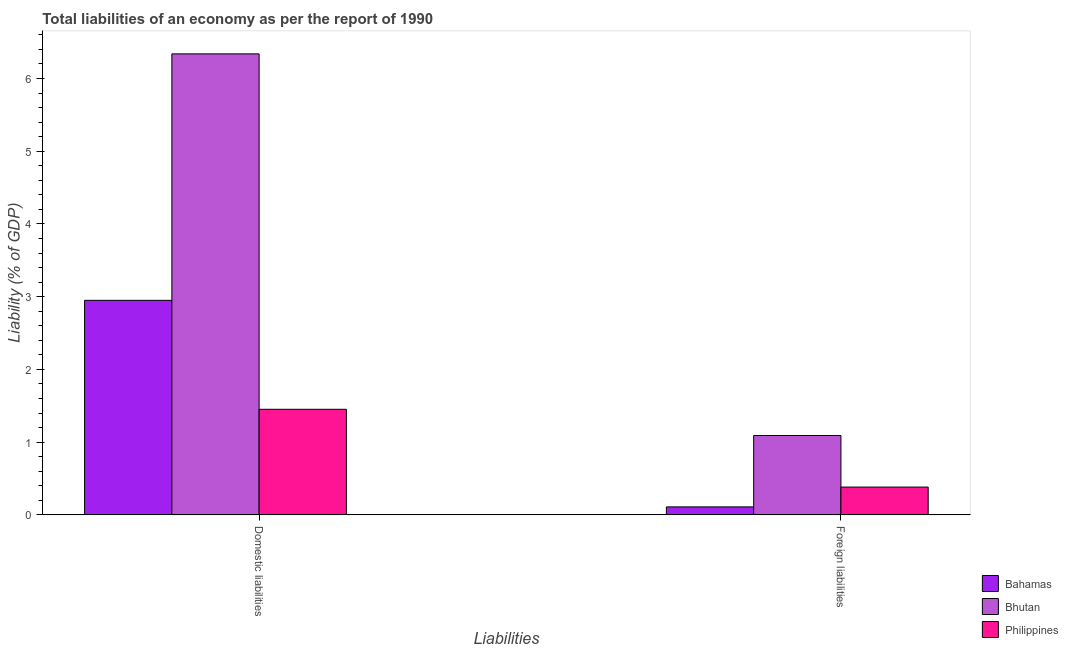How many groups of bars are there?
Your response must be concise. 2. Are the number of bars per tick equal to the number of legend labels?
Keep it short and to the point. Yes. Are the number of bars on each tick of the X-axis equal?
Your answer should be compact. Yes. How many bars are there on the 2nd tick from the left?
Ensure brevity in your answer.  3. How many bars are there on the 1st tick from the right?
Ensure brevity in your answer.  3. What is the label of the 2nd group of bars from the left?
Your answer should be very brief. Foreign liabilities. What is the incurrence of foreign liabilities in Bhutan?
Provide a short and direct response. 1.09. Across all countries, what is the maximum incurrence of domestic liabilities?
Offer a very short reply. 6.34. Across all countries, what is the minimum incurrence of foreign liabilities?
Offer a terse response. 0.11. In which country was the incurrence of foreign liabilities maximum?
Keep it short and to the point. Bhutan. In which country was the incurrence of foreign liabilities minimum?
Provide a succinct answer. Bahamas. What is the total incurrence of foreign liabilities in the graph?
Your response must be concise. 1.59. What is the difference between the incurrence of domestic liabilities in Philippines and that in Bhutan?
Offer a very short reply. -4.89. What is the difference between the incurrence of domestic liabilities in Bhutan and the incurrence of foreign liabilities in Philippines?
Provide a short and direct response. 5.96. What is the average incurrence of foreign liabilities per country?
Offer a very short reply. 0.53. What is the difference between the incurrence of domestic liabilities and incurrence of foreign liabilities in Philippines?
Ensure brevity in your answer.  1.07. What is the ratio of the incurrence of foreign liabilities in Philippines to that in Bhutan?
Provide a succinct answer. 0.35. Is the incurrence of foreign liabilities in Philippines less than that in Bahamas?
Your response must be concise. No. In how many countries, is the incurrence of domestic liabilities greater than the average incurrence of domestic liabilities taken over all countries?
Provide a short and direct response. 1. What does the 1st bar from the left in Foreign liabilities represents?
Ensure brevity in your answer.  Bahamas. What does the 3rd bar from the right in Foreign liabilities represents?
Keep it short and to the point. Bahamas. How many bars are there?
Keep it short and to the point. 6. Are all the bars in the graph horizontal?
Make the answer very short. No. How many countries are there in the graph?
Offer a terse response. 3. Are the values on the major ticks of Y-axis written in scientific E-notation?
Offer a terse response. No. Does the graph contain any zero values?
Keep it short and to the point. No. Does the graph contain grids?
Your answer should be compact. No. Where does the legend appear in the graph?
Your answer should be compact. Bottom right. How many legend labels are there?
Ensure brevity in your answer.  3. What is the title of the graph?
Ensure brevity in your answer.  Total liabilities of an economy as per the report of 1990. Does "Yemen, Rep." appear as one of the legend labels in the graph?
Make the answer very short. No. What is the label or title of the X-axis?
Offer a very short reply. Liabilities. What is the label or title of the Y-axis?
Make the answer very short. Liability (% of GDP). What is the Liability (% of GDP) in Bahamas in Domestic liabilities?
Provide a short and direct response. 2.95. What is the Liability (% of GDP) of Bhutan in Domestic liabilities?
Ensure brevity in your answer.  6.34. What is the Liability (% of GDP) of Philippines in Domestic liabilities?
Keep it short and to the point. 1.45. What is the Liability (% of GDP) of Bahamas in Foreign liabilities?
Keep it short and to the point. 0.11. What is the Liability (% of GDP) in Bhutan in Foreign liabilities?
Ensure brevity in your answer.  1.09. What is the Liability (% of GDP) in Philippines in Foreign liabilities?
Your answer should be very brief. 0.38. Across all Liabilities, what is the maximum Liability (% of GDP) in Bahamas?
Your answer should be very brief. 2.95. Across all Liabilities, what is the maximum Liability (% of GDP) of Bhutan?
Your answer should be very brief. 6.34. Across all Liabilities, what is the maximum Liability (% of GDP) in Philippines?
Offer a terse response. 1.45. Across all Liabilities, what is the minimum Liability (% of GDP) in Bahamas?
Ensure brevity in your answer.  0.11. Across all Liabilities, what is the minimum Liability (% of GDP) of Bhutan?
Your answer should be very brief. 1.09. Across all Liabilities, what is the minimum Liability (% of GDP) of Philippines?
Provide a succinct answer. 0.38. What is the total Liability (% of GDP) of Bahamas in the graph?
Give a very brief answer. 3.06. What is the total Liability (% of GDP) of Bhutan in the graph?
Your answer should be compact. 7.43. What is the total Liability (% of GDP) in Philippines in the graph?
Your response must be concise. 1.84. What is the difference between the Liability (% of GDP) in Bahamas in Domestic liabilities and that in Foreign liabilities?
Your response must be concise. 2.84. What is the difference between the Liability (% of GDP) in Bhutan in Domestic liabilities and that in Foreign liabilities?
Give a very brief answer. 5.25. What is the difference between the Liability (% of GDP) in Philippines in Domestic liabilities and that in Foreign liabilities?
Provide a short and direct response. 1.07. What is the difference between the Liability (% of GDP) of Bahamas in Domestic liabilities and the Liability (% of GDP) of Bhutan in Foreign liabilities?
Provide a short and direct response. 1.86. What is the difference between the Liability (% of GDP) of Bahamas in Domestic liabilities and the Liability (% of GDP) of Philippines in Foreign liabilities?
Provide a short and direct response. 2.57. What is the difference between the Liability (% of GDP) of Bhutan in Domestic liabilities and the Liability (% of GDP) of Philippines in Foreign liabilities?
Provide a succinct answer. 5.96. What is the average Liability (% of GDP) of Bahamas per Liabilities?
Give a very brief answer. 1.53. What is the average Liability (% of GDP) in Bhutan per Liabilities?
Make the answer very short. 3.71. What is the average Liability (% of GDP) of Philippines per Liabilities?
Your response must be concise. 0.92. What is the difference between the Liability (% of GDP) of Bahamas and Liability (% of GDP) of Bhutan in Domestic liabilities?
Ensure brevity in your answer.  -3.39. What is the difference between the Liability (% of GDP) of Bahamas and Liability (% of GDP) of Philippines in Domestic liabilities?
Give a very brief answer. 1.5. What is the difference between the Liability (% of GDP) of Bhutan and Liability (% of GDP) of Philippines in Domestic liabilities?
Provide a succinct answer. 4.89. What is the difference between the Liability (% of GDP) in Bahamas and Liability (% of GDP) in Bhutan in Foreign liabilities?
Your answer should be compact. -0.98. What is the difference between the Liability (% of GDP) in Bahamas and Liability (% of GDP) in Philippines in Foreign liabilities?
Your answer should be very brief. -0.27. What is the difference between the Liability (% of GDP) in Bhutan and Liability (% of GDP) in Philippines in Foreign liabilities?
Make the answer very short. 0.71. What is the ratio of the Liability (% of GDP) in Bahamas in Domestic liabilities to that in Foreign liabilities?
Provide a succinct answer. 26.69. What is the ratio of the Liability (% of GDP) of Bhutan in Domestic liabilities to that in Foreign liabilities?
Keep it short and to the point. 5.81. What is the ratio of the Liability (% of GDP) of Philippines in Domestic liabilities to that in Foreign liabilities?
Make the answer very short. 3.79. What is the difference between the highest and the second highest Liability (% of GDP) in Bahamas?
Provide a succinct answer. 2.84. What is the difference between the highest and the second highest Liability (% of GDP) of Bhutan?
Offer a very short reply. 5.25. What is the difference between the highest and the second highest Liability (% of GDP) in Philippines?
Provide a short and direct response. 1.07. What is the difference between the highest and the lowest Liability (% of GDP) of Bahamas?
Your response must be concise. 2.84. What is the difference between the highest and the lowest Liability (% of GDP) in Bhutan?
Your answer should be very brief. 5.25. What is the difference between the highest and the lowest Liability (% of GDP) of Philippines?
Offer a terse response. 1.07. 